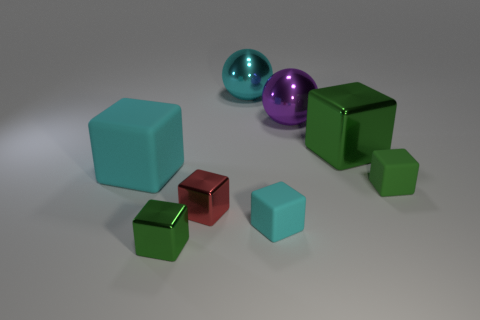Subtract all green cubes. How many were subtracted if there are1green cubes left? 2 Subtract all red balls. How many green blocks are left? 3 Subtract 2 cubes. How many cubes are left? 4 Subtract all cyan blocks. How many blocks are left? 4 Subtract all red blocks. How many blocks are left? 5 Subtract all yellow cubes. Subtract all blue spheres. How many cubes are left? 6 Add 2 tiny metal blocks. How many objects exist? 10 Subtract all blocks. How many objects are left? 2 Subtract all small green matte objects. Subtract all small green metal things. How many objects are left? 6 Add 3 balls. How many balls are left? 5 